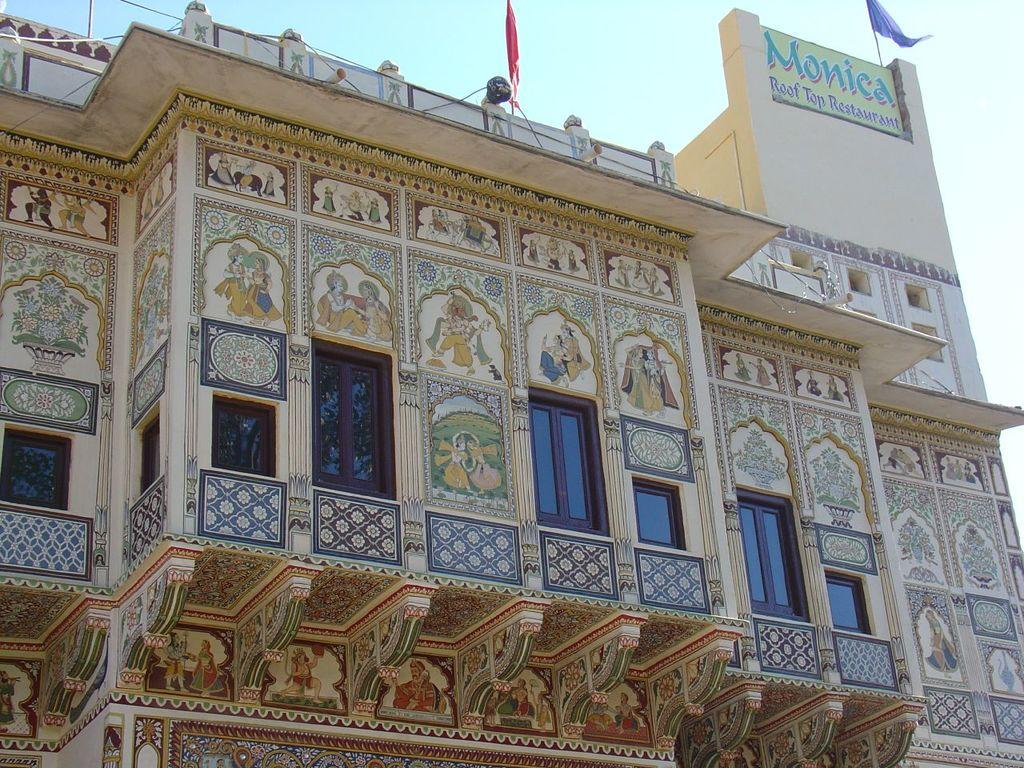What type of structure is present in the image? There is a building in the image. What feature can be seen on the building? The building has windows. What is displayed on the building? There is a hoarding on the building. What is visible at the top of the image? The sky is visible at the top of the image. What type of meat is being cooked on the calendar in the image? There is no calendar or meat present in the image. What type of cook is featured on the hoarding in the image? The hoarding on the building does not feature a cook; it is an advertisement or display for something else. 